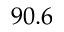Convert formula to latex. <formula><loc_0><loc_0><loc_500><loc_500>9 0 . 6</formula> 